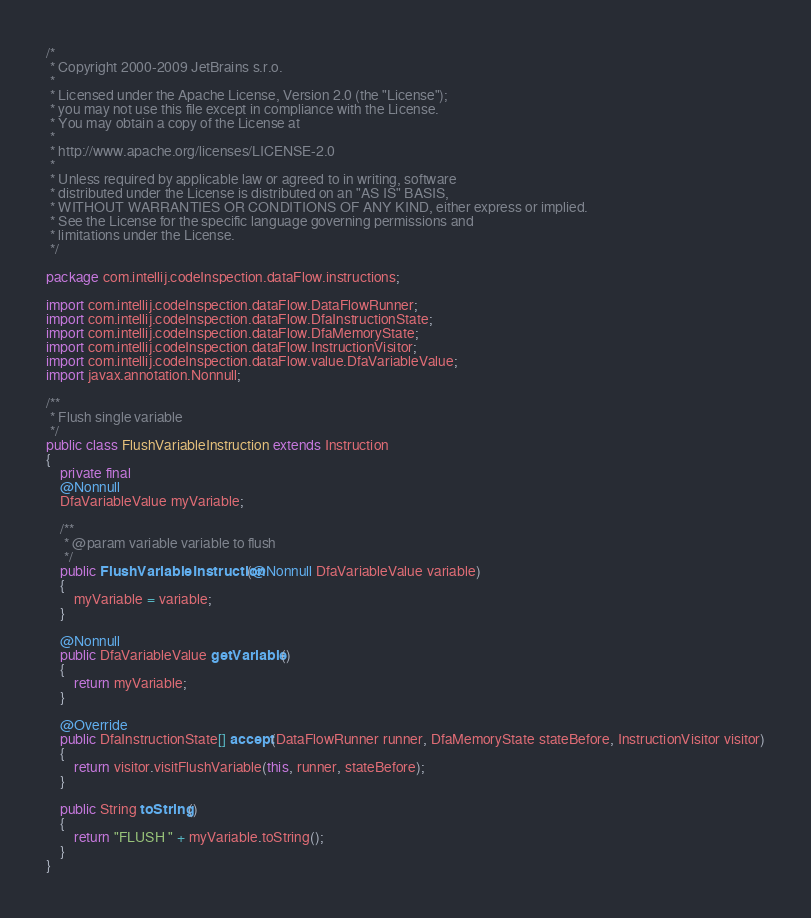<code> <loc_0><loc_0><loc_500><loc_500><_Java_>/*
 * Copyright 2000-2009 JetBrains s.r.o.
 *
 * Licensed under the Apache License, Version 2.0 (the "License");
 * you may not use this file except in compliance with the License.
 * You may obtain a copy of the License at
 *
 * http://www.apache.org/licenses/LICENSE-2.0
 *
 * Unless required by applicable law or agreed to in writing, software
 * distributed under the License is distributed on an "AS IS" BASIS,
 * WITHOUT WARRANTIES OR CONDITIONS OF ANY KIND, either express or implied.
 * See the License for the specific language governing permissions and
 * limitations under the License.
 */

package com.intellij.codeInspection.dataFlow.instructions;

import com.intellij.codeInspection.dataFlow.DataFlowRunner;
import com.intellij.codeInspection.dataFlow.DfaInstructionState;
import com.intellij.codeInspection.dataFlow.DfaMemoryState;
import com.intellij.codeInspection.dataFlow.InstructionVisitor;
import com.intellij.codeInspection.dataFlow.value.DfaVariableValue;
import javax.annotation.Nonnull;

/**
 * Flush single variable
 */
public class FlushVariableInstruction extends Instruction
{
	private final
	@Nonnull
	DfaVariableValue myVariable;

	/**
	 * @param variable variable to flush
	 */
	public FlushVariableInstruction(@Nonnull DfaVariableValue variable)
	{
		myVariable = variable;
	}

	@Nonnull
	public DfaVariableValue getVariable()
	{
		return myVariable;
	}

	@Override
	public DfaInstructionState[] accept(DataFlowRunner runner, DfaMemoryState stateBefore, InstructionVisitor visitor)
	{
		return visitor.visitFlushVariable(this, runner, stateBefore);
	}

	public String toString()
	{
		return "FLUSH " + myVariable.toString();
	}
}
</code> 